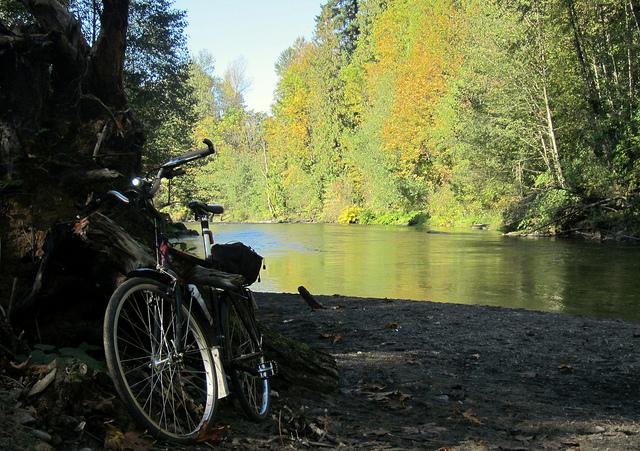What type of animal might you see in the environment in the middle of the photo?
Write a very short answer. Fish. Is this a pond?
Answer briefly. Yes. Is the bicycle moving?
Give a very brief answer. No. Where is the bike parked?
Short answer required. Against tree. What kind of vehicle is in the scene?
Answer briefly. Bicycle. 